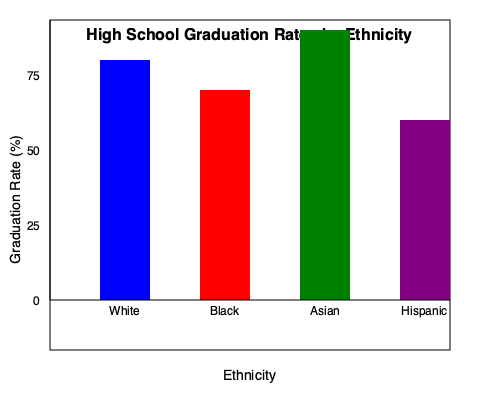As a university recruitment officer, you're analyzing high school graduation rates to inform your outreach strategies. Based on the graph, which ethnicity shows the highest graduation rate, and what is the approximate percentage difference between the highest and lowest graduation rates? To answer this question, we need to follow these steps:

1. Identify the highest graduation rate:
   - White: approximately 80%
   - Black: approximately 70%
   - Asian: approximately 90%
   - Hispanic: approximately 60%
   
   The highest graduation rate is for Asian students at approximately 90%.

2. Identify the lowest graduation rate:
   The lowest graduation rate is for Hispanic students at approximately 60%.

3. Calculate the difference between the highest and lowest rates:
   $90% - 60% = 30%$

Therefore, Asian students have the highest graduation rate, and the approximate percentage difference between the highest (Asian) and lowest (Hispanic) graduation rates is 30%.
Answer: Asian; 30% 